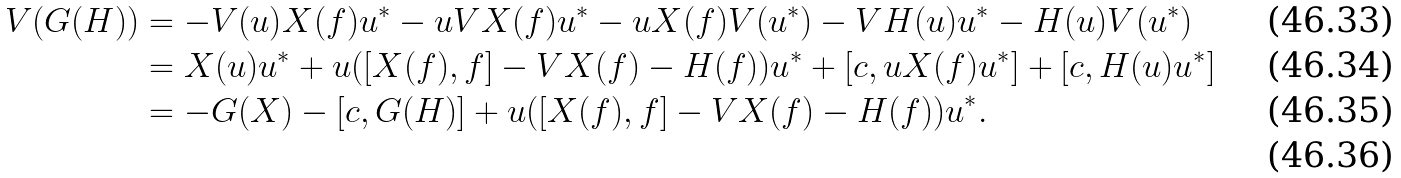Convert formula to latex. <formula><loc_0><loc_0><loc_500><loc_500>V ( G ( H ) ) & = - V ( u ) X ( f ) u ^ { * } - u V X ( f ) u ^ { * } - u X ( f ) V ( u ^ { * } ) - V H ( u ) u ^ { * } - H ( u ) V ( u ^ { * } ) \\ & = X ( u ) u ^ { * } + u ( [ X ( f ) , f ] - V X ( f ) - H ( f ) ) u ^ { * } + [ c , u X ( f ) u ^ { * } ] + [ c , H ( u ) u ^ { * } ] \\ & = - G ( X ) - [ c , G ( H ) ] + u ( [ X ( f ) , f ] - V X ( f ) - H ( f ) ) u ^ { * } . \\</formula> 